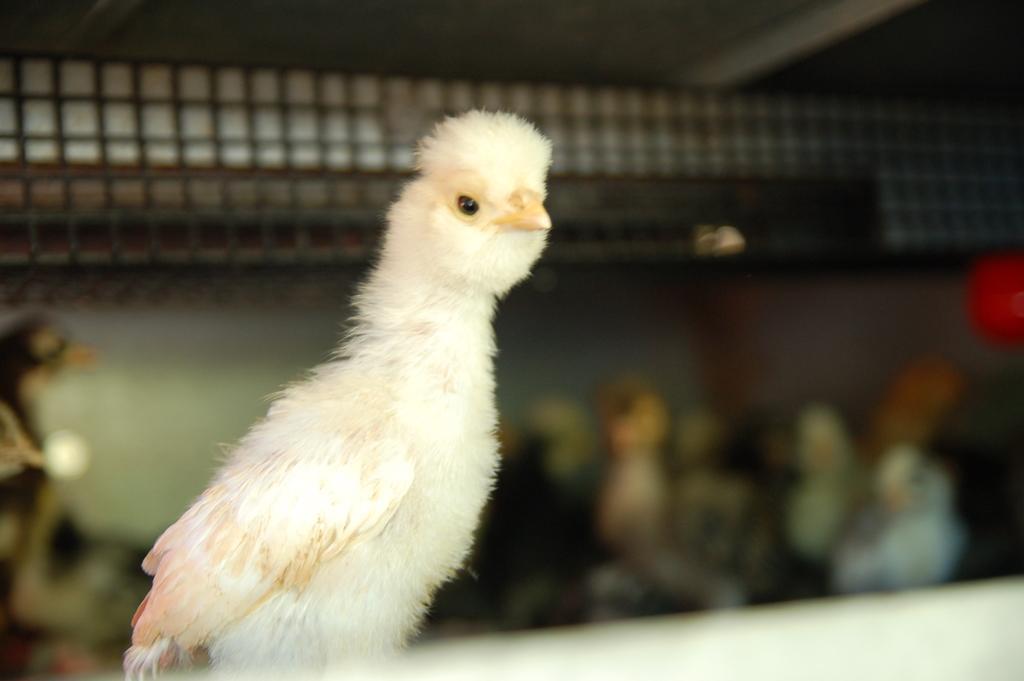In one or two sentences, can you explain what this image depicts? In this picture I can see a bird and looks like few people in the background 